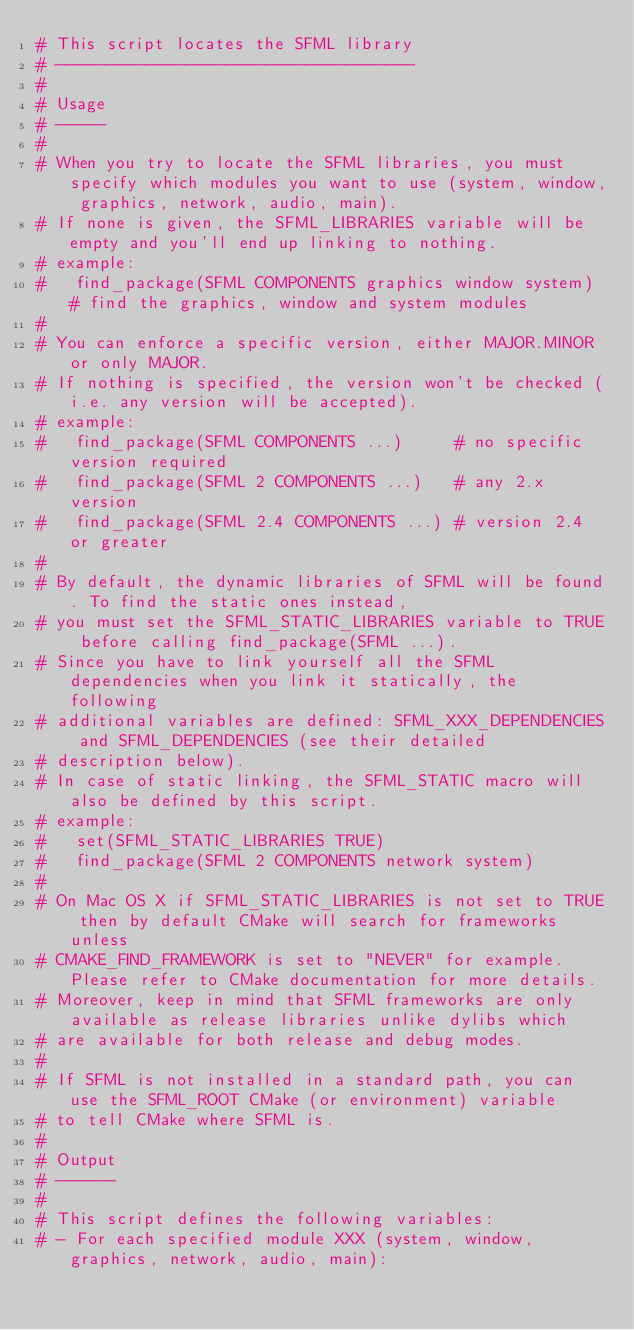Convert code to text. <code><loc_0><loc_0><loc_500><loc_500><_CMake_># This script locates the SFML library
# ------------------------------------
#
# Usage
# -----
#
# When you try to locate the SFML libraries, you must specify which modules you want to use (system, window, graphics, network, audio, main).
# If none is given, the SFML_LIBRARIES variable will be empty and you'll end up linking to nothing.
# example:
#   find_package(SFML COMPONENTS graphics window system) # find the graphics, window and system modules
#
# You can enforce a specific version, either MAJOR.MINOR or only MAJOR.
# If nothing is specified, the version won't be checked (i.e. any version will be accepted).
# example:
#   find_package(SFML COMPONENTS ...)     # no specific version required
#   find_package(SFML 2 COMPONENTS ...)   # any 2.x version
#   find_package(SFML 2.4 COMPONENTS ...) # version 2.4 or greater
#
# By default, the dynamic libraries of SFML will be found. To find the static ones instead,
# you must set the SFML_STATIC_LIBRARIES variable to TRUE before calling find_package(SFML ...).
# Since you have to link yourself all the SFML dependencies when you link it statically, the following
# additional variables are defined: SFML_XXX_DEPENDENCIES and SFML_DEPENDENCIES (see their detailed
# description below).
# In case of static linking, the SFML_STATIC macro will also be defined by this script.
# example:
#   set(SFML_STATIC_LIBRARIES TRUE)
#   find_package(SFML 2 COMPONENTS network system)
#
# On Mac OS X if SFML_STATIC_LIBRARIES is not set to TRUE then by default CMake will search for frameworks unless
# CMAKE_FIND_FRAMEWORK is set to "NEVER" for example. Please refer to CMake documentation for more details.
# Moreover, keep in mind that SFML frameworks are only available as release libraries unlike dylibs which
# are available for both release and debug modes.
#
# If SFML is not installed in a standard path, you can use the SFML_ROOT CMake (or environment) variable
# to tell CMake where SFML is.
#
# Output
# ------
#
# This script defines the following variables:
# - For each specified module XXX (system, window, graphics, network, audio, main):</code> 